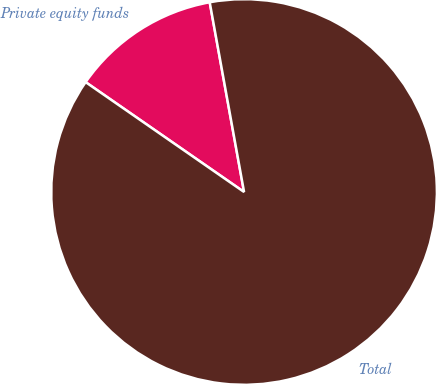Convert chart to OTSL. <chart><loc_0><loc_0><loc_500><loc_500><pie_chart><fcel>Private equity funds<fcel>Total<nl><fcel>12.5%<fcel>87.5%<nl></chart> 